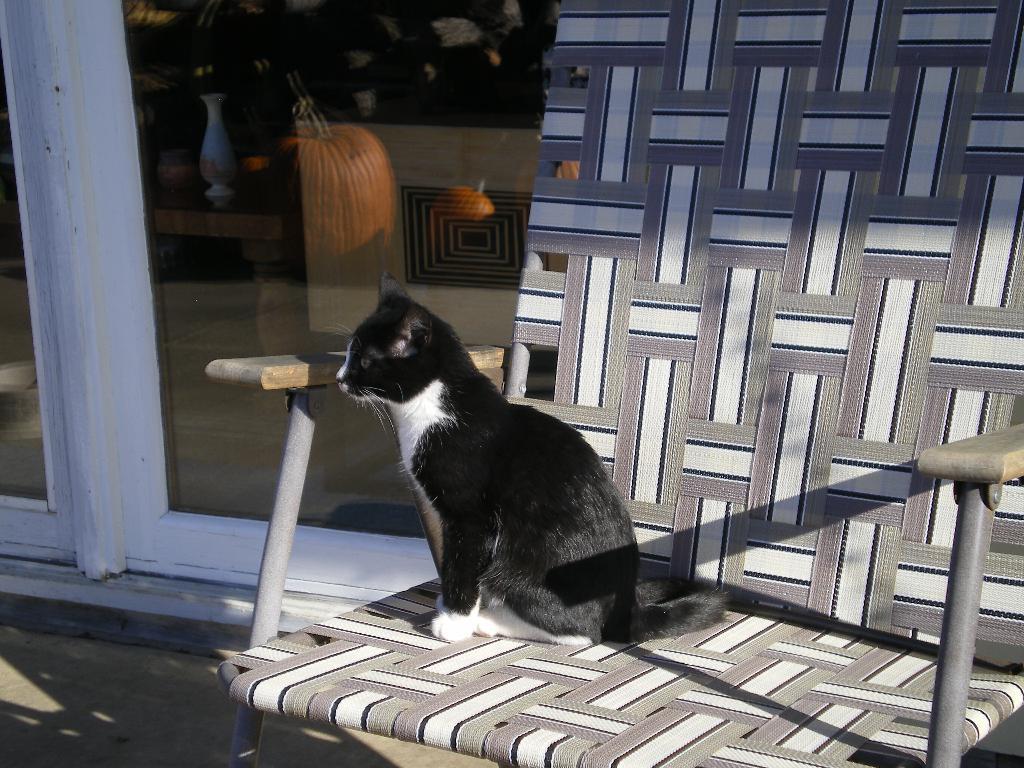Could you give a brief overview of what you see in this image? In this picture there is black and white color cat sitting on the chair. Behind there is a glass and wooden white color door. 